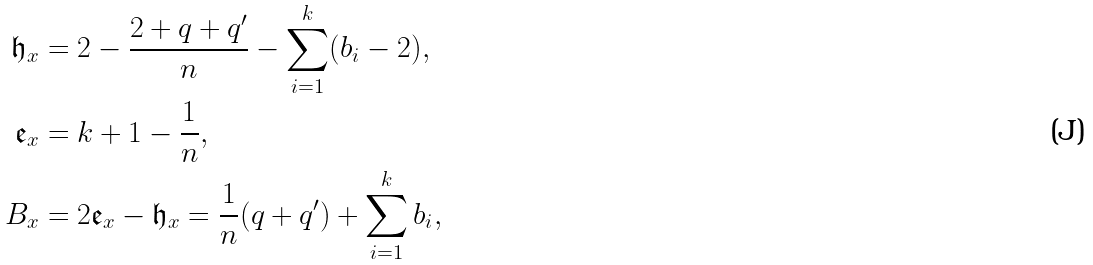<formula> <loc_0><loc_0><loc_500><loc_500>\mathfrak { h } _ { x } & = 2 - \frac { 2 + q + q ^ { \prime } } { n } - \sum _ { i = 1 } ^ { k } ( b _ { i } - 2 ) , \\ \mathfrak { e } _ { x } & = k + 1 - \frac { 1 } { n } , \\ B _ { x } & = 2 \mathfrak { e } _ { x } - \mathfrak { h } _ { x } = \frac { 1 } { n } ( q + q ^ { \prime } ) + \sum _ { i = 1 } ^ { k } b _ { i } ,</formula> 